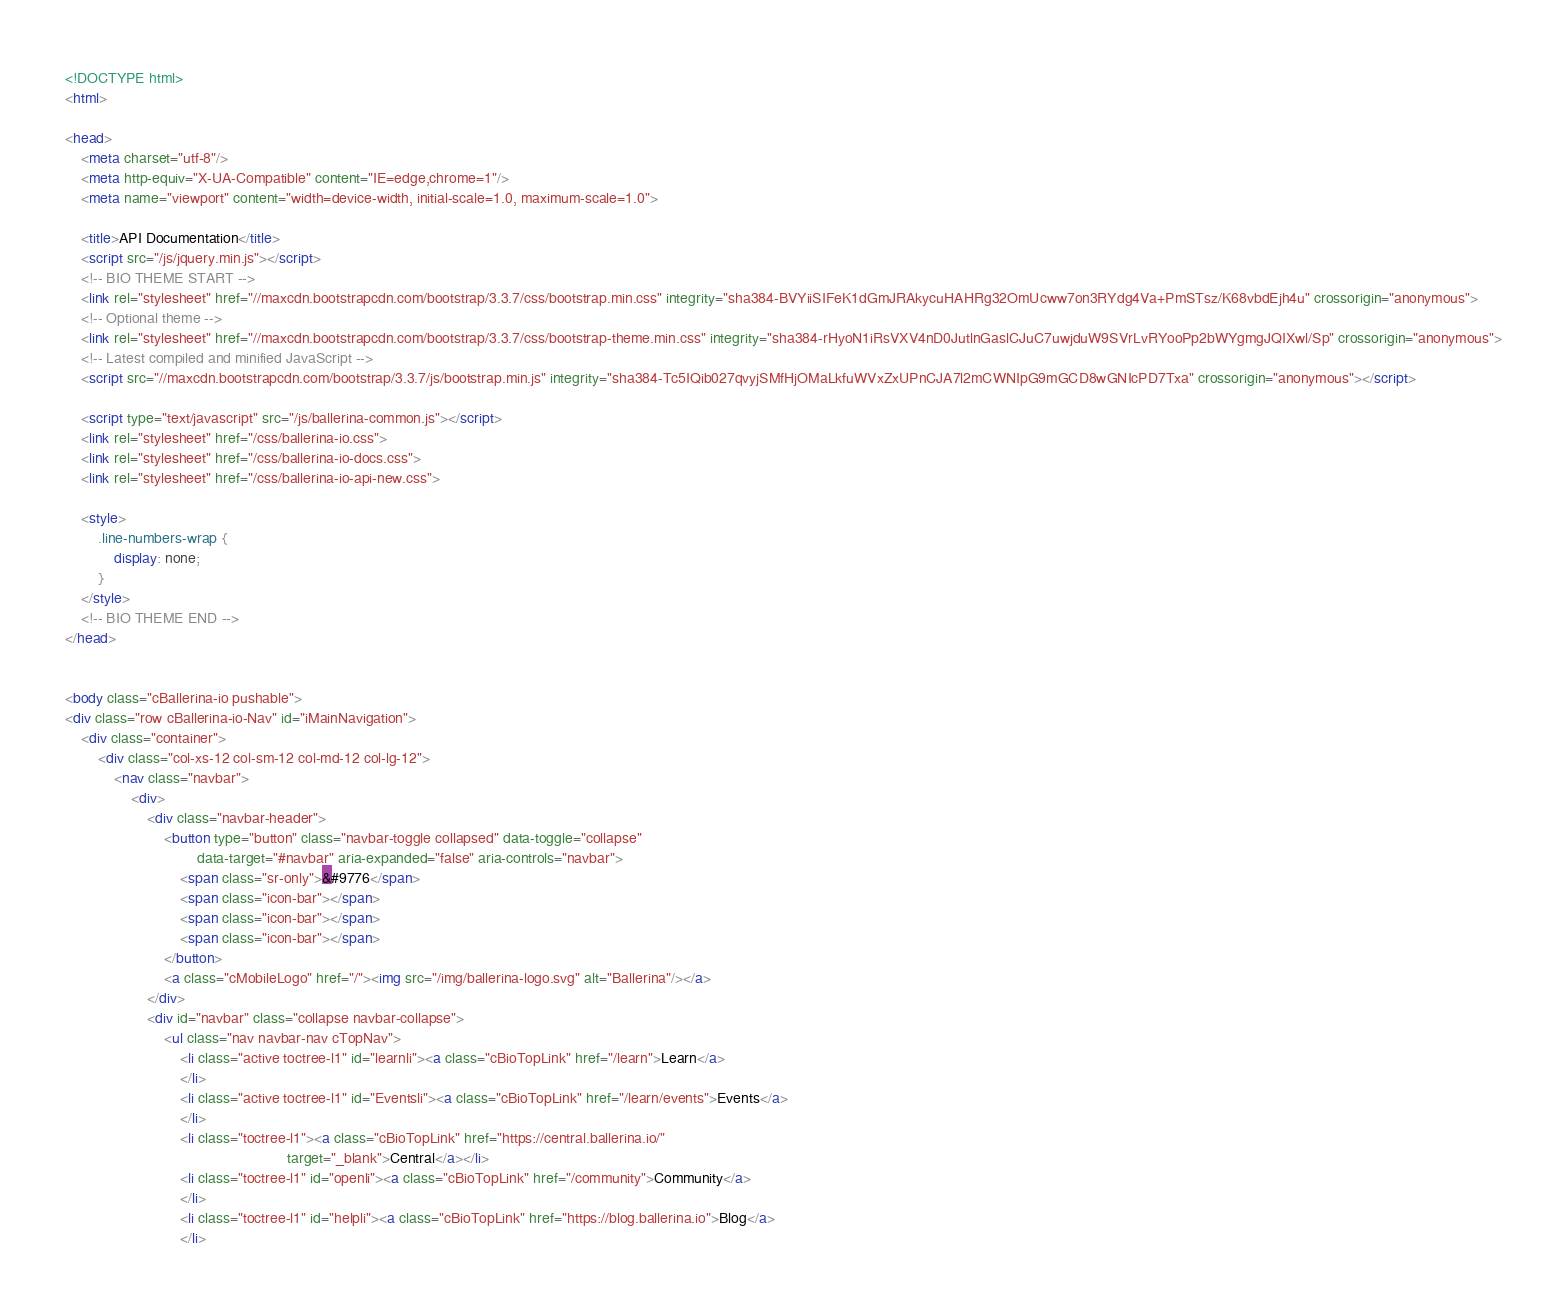Convert code to text. <code><loc_0><loc_0><loc_500><loc_500><_HTML_><!DOCTYPE html>
<html>

<head>
    <meta charset="utf-8"/>
    <meta http-equiv="X-UA-Compatible" content="IE=edge,chrome=1"/>
    <meta name="viewport" content="width=device-width, initial-scale=1.0, maximum-scale=1.0">

    <title>API Documentation</title>
    <script src="/js/jquery.min.js"></script>
    <!-- BIO THEME START -->
    <link rel="stylesheet" href="//maxcdn.bootstrapcdn.com/bootstrap/3.3.7/css/bootstrap.min.css" integrity="sha384-BVYiiSIFeK1dGmJRAkycuHAHRg32OmUcww7on3RYdg4Va+PmSTsz/K68vbdEjh4u" crossorigin="anonymous">
    <!-- Optional theme -->
    <link rel="stylesheet" href="//maxcdn.bootstrapcdn.com/bootstrap/3.3.7/css/bootstrap-theme.min.css" integrity="sha384-rHyoN1iRsVXV4nD0JutlnGaslCJuC7uwjduW9SVrLvRYooPp2bWYgmgJQIXwl/Sp" crossorigin="anonymous">
    <!-- Latest compiled and minified JavaScript -->
    <script src="//maxcdn.bootstrapcdn.com/bootstrap/3.3.7/js/bootstrap.min.js" integrity="sha384-Tc5IQib027qvyjSMfHjOMaLkfuWVxZxUPnCJA7l2mCWNIpG9mGCD8wGNIcPD7Txa" crossorigin="anonymous"></script>

    <script type="text/javascript" src="/js/ballerina-common.js"></script>
    <link rel="stylesheet" href="/css/ballerina-io.css">
    <link rel="stylesheet" href="/css/ballerina-io-docs.css">
    <link rel="stylesheet" href="/css/ballerina-io-api-new.css">

    <style>
        .line-numbers-wrap {
            display: none;
        }
    </style>
    <!-- BIO THEME END -->
</head>


<body class="cBallerina-io pushable">
<div class="row cBallerina-io-Nav" id="iMainNavigation">
    <div class="container">
        <div class="col-xs-12 col-sm-12 col-md-12 col-lg-12">
            <nav class="navbar">
                <div>
                    <div class="navbar-header">
                        <button type="button" class="navbar-toggle collapsed" data-toggle="collapse"
                                data-target="#navbar" aria-expanded="false" aria-controls="navbar">
                            <span class="sr-only">&#9776</span>
                            <span class="icon-bar"></span>
                            <span class="icon-bar"></span>
                            <span class="icon-bar"></span>
                        </button>
                        <a class="cMobileLogo" href="/"><img src="/img/ballerina-logo.svg" alt="Ballerina"/></a>
                    </div>
                    <div id="navbar" class="collapse navbar-collapse">
                        <ul class="nav navbar-nav cTopNav">
                            <li class="active toctree-l1" id="learnli"><a class="cBioTopLink" href="/learn">Learn</a>
                            </li>
                            <li class="active toctree-l1" id="Eventsli"><a class="cBioTopLink" href="/learn/events">Events</a>
                            </li>
                            <li class="toctree-l1"><a class="cBioTopLink" href="https://central.ballerina.io/"
                                                      target="_blank">Central</a></li>
                            <li class="toctree-l1" id="openli"><a class="cBioTopLink" href="/community">Community</a>
                            </li>
                            <li class="toctree-l1" id="helpli"><a class="cBioTopLink" href="https://blog.ballerina.io">Blog</a>
                            </li></code> 